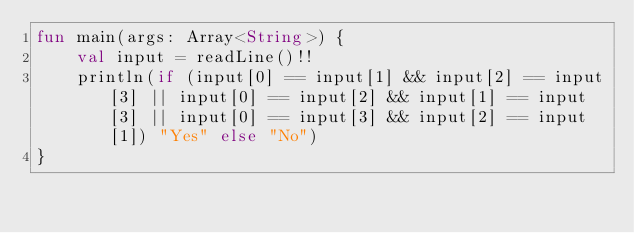Convert code to text. <code><loc_0><loc_0><loc_500><loc_500><_Kotlin_>fun main(args: Array<String>) {
    val input = readLine()!!
    println(if (input[0] == input[1] && input[2] == input[3] || input[0] == input[2] && input[1] == input[3] || input[0] == input[3] && input[2] == input[1]) "Yes" else "No")
}</code> 